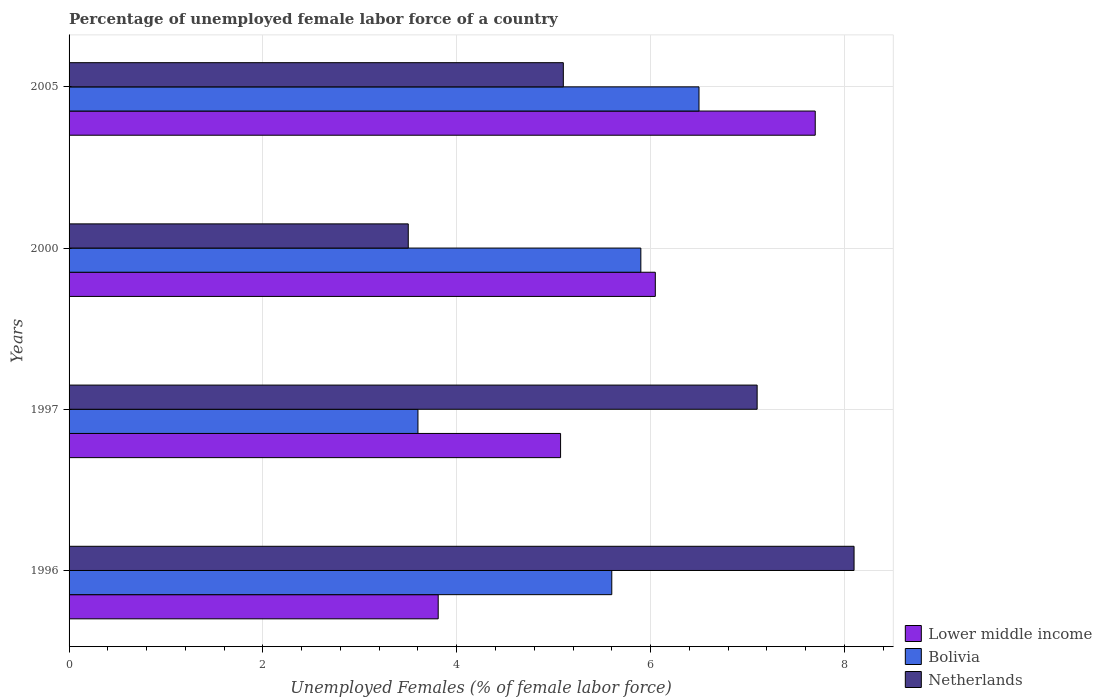How many different coloured bars are there?
Make the answer very short. 3. How many bars are there on the 4th tick from the top?
Your answer should be compact. 3. How many bars are there on the 4th tick from the bottom?
Make the answer very short. 3. What is the label of the 2nd group of bars from the top?
Keep it short and to the point. 2000. In how many cases, is the number of bars for a given year not equal to the number of legend labels?
Offer a terse response. 0. What is the percentage of unemployed female labor force in Lower middle income in 2005?
Your response must be concise. 7.7. Across all years, what is the maximum percentage of unemployed female labor force in Netherlands?
Provide a short and direct response. 8.1. Across all years, what is the minimum percentage of unemployed female labor force in Lower middle income?
Your answer should be very brief. 3.81. In which year was the percentage of unemployed female labor force in Lower middle income maximum?
Your answer should be compact. 2005. What is the total percentage of unemployed female labor force in Lower middle income in the graph?
Provide a short and direct response. 22.63. What is the difference between the percentage of unemployed female labor force in Bolivia in 1997 and that in 2005?
Offer a very short reply. -2.9. What is the difference between the percentage of unemployed female labor force in Bolivia in 2005 and the percentage of unemployed female labor force in Netherlands in 1997?
Keep it short and to the point. -0.6. What is the average percentage of unemployed female labor force in Lower middle income per year?
Ensure brevity in your answer.  5.66. In the year 1997, what is the difference between the percentage of unemployed female labor force in Netherlands and percentage of unemployed female labor force in Bolivia?
Your answer should be very brief. 3.5. What is the ratio of the percentage of unemployed female labor force in Bolivia in 1996 to that in 2000?
Provide a short and direct response. 0.95. Is the percentage of unemployed female labor force in Bolivia in 2000 less than that in 2005?
Provide a short and direct response. Yes. Is the difference between the percentage of unemployed female labor force in Netherlands in 2000 and 2005 greater than the difference between the percentage of unemployed female labor force in Bolivia in 2000 and 2005?
Your answer should be very brief. No. What is the difference between the highest and the second highest percentage of unemployed female labor force in Bolivia?
Ensure brevity in your answer.  0.6. What is the difference between the highest and the lowest percentage of unemployed female labor force in Netherlands?
Provide a succinct answer. 4.6. Is the sum of the percentage of unemployed female labor force in Netherlands in 1996 and 1997 greater than the maximum percentage of unemployed female labor force in Bolivia across all years?
Ensure brevity in your answer.  Yes. What does the 1st bar from the bottom in 1996 represents?
Make the answer very short. Lower middle income. Are all the bars in the graph horizontal?
Your answer should be very brief. Yes. How many years are there in the graph?
Provide a short and direct response. 4. What is the difference between two consecutive major ticks on the X-axis?
Ensure brevity in your answer.  2. Are the values on the major ticks of X-axis written in scientific E-notation?
Offer a very short reply. No. Where does the legend appear in the graph?
Offer a terse response. Bottom right. How many legend labels are there?
Make the answer very short. 3. How are the legend labels stacked?
Provide a succinct answer. Vertical. What is the title of the graph?
Your answer should be very brief. Percentage of unemployed female labor force of a country. Does "United Arab Emirates" appear as one of the legend labels in the graph?
Provide a short and direct response. No. What is the label or title of the X-axis?
Your answer should be compact. Unemployed Females (% of female labor force). What is the Unemployed Females (% of female labor force) in Lower middle income in 1996?
Your answer should be compact. 3.81. What is the Unemployed Females (% of female labor force) of Bolivia in 1996?
Your response must be concise. 5.6. What is the Unemployed Females (% of female labor force) of Netherlands in 1996?
Ensure brevity in your answer.  8.1. What is the Unemployed Females (% of female labor force) of Lower middle income in 1997?
Ensure brevity in your answer.  5.07. What is the Unemployed Females (% of female labor force) in Bolivia in 1997?
Keep it short and to the point. 3.6. What is the Unemployed Females (% of female labor force) of Netherlands in 1997?
Keep it short and to the point. 7.1. What is the Unemployed Females (% of female labor force) of Lower middle income in 2000?
Provide a short and direct response. 6.05. What is the Unemployed Females (% of female labor force) of Bolivia in 2000?
Provide a succinct answer. 5.9. What is the Unemployed Females (% of female labor force) of Lower middle income in 2005?
Keep it short and to the point. 7.7. What is the Unemployed Females (% of female labor force) in Bolivia in 2005?
Ensure brevity in your answer.  6.5. What is the Unemployed Females (% of female labor force) of Netherlands in 2005?
Provide a short and direct response. 5.1. Across all years, what is the maximum Unemployed Females (% of female labor force) in Lower middle income?
Offer a terse response. 7.7. Across all years, what is the maximum Unemployed Females (% of female labor force) of Netherlands?
Your response must be concise. 8.1. Across all years, what is the minimum Unemployed Females (% of female labor force) in Lower middle income?
Make the answer very short. 3.81. Across all years, what is the minimum Unemployed Females (% of female labor force) in Bolivia?
Your answer should be compact. 3.6. What is the total Unemployed Females (% of female labor force) in Lower middle income in the graph?
Your answer should be compact. 22.63. What is the total Unemployed Females (% of female labor force) of Bolivia in the graph?
Keep it short and to the point. 21.6. What is the total Unemployed Females (% of female labor force) of Netherlands in the graph?
Provide a short and direct response. 23.8. What is the difference between the Unemployed Females (% of female labor force) in Lower middle income in 1996 and that in 1997?
Ensure brevity in your answer.  -1.26. What is the difference between the Unemployed Females (% of female labor force) in Bolivia in 1996 and that in 1997?
Keep it short and to the point. 2. What is the difference between the Unemployed Females (% of female labor force) in Lower middle income in 1996 and that in 2000?
Offer a very short reply. -2.24. What is the difference between the Unemployed Females (% of female labor force) in Bolivia in 1996 and that in 2000?
Your answer should be very brief. -0.3. What is the difference between the Unemployed Females (% of female labor force) in Netherlands in 1996 and that in 2000?
Provide a short and direct response. 4.6. What is the difference between the Unemployed Females (% of female labor force) of Lower middle income in 1996 and that in 2005?
Offer a very short reply. -3.89. What is the difference between the Unemployed Females (% of female labor force) in Bolivia in 1996 and that in 2005?
Your answer should be very brief. -0.9. What is the difference between the Unemployed Females (% of female labor force) in Netherlands in 1996 and that in 2005?
Keep it short and to the point. 3. What is the difference between the Unemployed Females (% of female labor force) in Lower middle income in 1997 and that in 2000?
Provide a succinct answer. -0.98. What is the difference between the Unemployed Females (% of female labor force) of Bolivia in 1997 and that in 2000?
Give a very brief answer. -2.3. What is the difference between the Unemployed Females (% of female labor force) of Netherlands in 1997 and that in 2000?
Keep it short and to the point. 3.6. What is the difference between the Unemployed Females (% of female labor force) of Lower middle income in 1997 and that in 2005?
Your answer should be very brief. -2.63. What is the difference between the Unemployed Females (% of female labor force) of Bolivia in 1997 and that in 2005?
Provide a short and direct response. -2.9. What is the difference between the Unemployed Females (% of female labor force) in Lower middle income in 2000 and that in 2005?
Offer a terse response. -1.65. What is the difference between the Unemployed Females (% of female labor force) of Lower middle income in 1996 and the Unemployed Females (% of female labor force) of Bolivia in 1997?
Your answer should be very brief. 0.21. What is the difference between the Unemployed Females (% of female labor force) of Lower middle income in 1996 and the Unemployed Females (% of female labor force) of Netherlands in 1997?
Give a very brief answer. -3.29. What is the difference between the Unemployed Females (% of female labor force) of Bolivia in 1996 and the Unemployed Females (% of female labor force) of Netherlands in 1997?
Ensure brevity in your answer.  -1.5. What is the difference between the Unemployed Females (% of female labor force) of Lower middle income in 1996 and the Unemployed Females (% of female labor force) of Bolivia in 2000?
Your answer should be compact. -2.09. What is the difference between the Unemployed Females (% of female labor force) in Lower middle income in 1996 and the Unemployed Females (% of female labor force) in Netherlands in 2000?
Your response must be concise. 0.31. What is the difference between the Unemployed Females (% of female labor force) of Bolivia in 1996 and the Unemployed Females (% of female labor force) of Netherlands in 2000?
Give a very brief answer. 2.1. What is the difference between the Unemployed Females (% of female labor force) of Lower middle income in 1996 and the Unemployed Females (% of female labor force) of Bolivia in 2005?
Provide a succinct answer. -2.69. What is the difference between the Unemployed Females (% of female labor force) in Lower middle income in 1996 and the Unemployed Females (% of female labor force) in Netherlands in 2005?
Provide a succinct answer. -1.29. What is the difference between the Unemployed Females (% of female labor force) of Bolivia in 1996 and the Unemployed Females (% of female labor force) of Netherlands in 2005?
Provide a succinct answer. 0.5. What is the difference between the Unemployed Females (% of female labor force) of Lower middle income in 1997 and the Unemployed Females (% of female labor force) of Bolivia in 2000?
Your answer should be very brief. -0.83. What is the difference between the Unemployed Females (% of female labor force) in Lower middle income in 1997 and the Unemployed Females (% of female labor force) in Netherlands in 2000?
Offer a terse response. 1.57. What is the difference between the Unemployed Females (% of female labor force) of Lower middle income in 1997 and the Unemployed Females (% of female labor force) of Bolivia in 2005?
Ensure brevity in your answer.  -1.43. What is the difference between the Unemployed Females (% of female labor force) of Lower middle income in 1997 and the Unemployed Females (% of female labor force) of Netherlands in 2005?
Provide a short and direct response. -0.03. What is the difference between the Unemployed Females (% of female labor force) of Bolivia in 1997 and the Unemployed Females (% of female labor force) of Netherlands in 2005?
Keep it short and to the point. -1.5. What is the difference between the Unemployed Females (% of female labor force) of Lower middle income in 2000 and the Unemployed Females (% of female labor force) of Bolivia in 2005?
Offer a terse response. -0.45. What is the difference between the Unemployed Females (% of female labor force) in Lower middle income in 2000 and the Unemployed Females (% of female labor force) in Netherlands in 2005?
Offer a terse response. 0.95. What is the difference between the Unemployed Females (% of female labor force) of Bolivia in 2000 and the Unemployed Females (% of female labor force) of Netherlands in 2005?
Provide a succinct answer. 0.8. What is the average Unemployed Females (% of female labor force) in Lower middle income per year?
Provide a succinct answer. 5.66. What is the average Unemployed Females (% of female labor force) in Netherlands per year?
Make the answer very short. 5.95. In the year 1996, what is the difference between the Unemployed Females (% of female labor force) in Lower middle income and Unemployed Females (% of female labor force) in Bolivia?
Give a very brief answer. -1.79. In the year 1996, what is the difference between the Unemployed Females (% of female labor force) of Lower middle income and Unemployed Females (% of female labor force) of Netherlands?
Provide a short and direct response. -4.29. In the year 1996, what is the difference between the Unemployed Females (% of female labor force) in Bolivia and Unemployed Females (% of female labor force) in Netherlands?
Keep it short and to the point. -2.5. In the year 1997, what is the difference between the Unemployed Females (% of female labor force) of Lower middle income and Unemployed Females (% of female labor force) of Bolivia?
Make the answer very short. 1.47. In the year 1997, what is the difference between the Unemployed Females (% of female labor force) of Lower middle income and Unemployed Females (% of female labor force) of Netherlands?
Provide a short and direct response. -2.03. In the year 1997, what is the difference between the Unemployed Females (% of female labor force) of Bolivia and Unemployed Females (% of female labor force) of Netherlands?
Offer a very short reply. -3.5. In the year 2000, what is the difference between the Unemployed Females (% of female labor force) in Lower middle income and Unemployed Females (% of female labor force) in Bolivia?
Provide a short and direct response. 0.15. In the year 2000, what is the difference between the Unemployed Females (% of female labor force) in Lower middle income and Unemployed Females (% of female labor force) in Netherlands?
Offer a very short reply. 2.55. In the year 2000, what is the difference between the Unemployed Females (% of female labor force) in Bolivia and Unemployed Females (% of female labor force) in Netherlands?
Make the answer very short. 2.4. In the year 2005, what is the difference between the Unemployed Females (% of female labor force) in Lower middle income and Unemployed Females (% of female labor force) in Bolivia?
Offer a terse response. 1.2. In the year 2005, what is the difference between the Unemployed Females (% of female labor force) of Lower middle income and Unemployed Females (% of female labor force) of Netherlands?
Offer a terse response. 2.6. In the year 2005, what is the difference between the Unemployed Females (% of female labor force) in Bolivia and Unemployed Females (% of female labor force) in Netherlands?
Your response must be concise. 1.4. What is the ratio of the Unemployed Females (% of female labor force) in Lower middle income in 1996 to that in 1997?
Give a very brief answer. 0.75. What is the ratio of the Unemployed Females (% of female labor force) of Bolivia in 1996 to that in 1997?
Your response must be concise. 1.56. What is the ratio of the Unemployed Females (% of female labor force) of Netherlands in 1996 to that in 1997?
Your answer should be very brief. 1.14. What is the ratio of the Unemployed Females (% of female labor force) of Lower middle income in 1996 to that in 2000?
Provide a short and direct response. 0.63. What is the ratio of the Unemployed Females (% of female labor force) of Bolivia in 1996 to that in 2000?
Offer a very short reply. 0.95. What is the ratio of the Unemployed Females (% of female labor force) in Netherlands in 1996 to that in 2000?
Your answer should be very brief. 2.31. What is the ratio of the Unemployed Females (% of female labor force) in Lower middle income in 1996 to that in 2005?
Provide a succinct answer. 0.49. What is the ratio of the Unemployed Females (% of female labor force) of Bolivia in 1996 to that in 2005?
Your answer should be compact. 0.86. What is the ratio of the Unemployed Females (% of female labor force) of Netherlands in 1996 to that in 2005?
Offer a terse response. 1.59. What is the ratio of the Unemployed Females (% of female labor force) in Lower middle income in 1997 to that in 2000?
Offer a very short reply. 0.84. What is the ratio of the Unemployed Females (% of female labor force) of Bolivia in 1997 to that in 2000?
Offer a very short reply. 0.61. What is the ratio of the Unemployed Females (% of female labor force) in Netherlands in 1997 to that in 2000?
Your answer should be very brief. 2.03. What is the ratio of the Unemployed Females (% of female labor force) of Lower middle income in 1997 to that in 2005?
Make the answer very short. 0.66. What is the ratio of the Unemployed Females (% of female labor force) in Bolivia in 1997 to that in 2005?
Ensure brevity in your answer.  0.55. What is the ratio of the Unemployed Females (% of female labor force) in Netherlands in 1997 to that in 2005?
Offer a terse response. 1.39. What is the ratio of the Unemployed Females (% of female labor force) of Lower middle income in 2000 to that in 2005?
Your answer should be very brief. 0.79. What is the ratio of the Unemployed Females (% of female labor force) of Bolivia in 2000 to that in 2005?
Provide a short and direct response. 0.91. What is the ratio of the Unemployed Females (% of female labor force) in Netherlands in 2000 to that in 2005?
Your answer should be very brief. 0.69. What is the difference between the highest and the second highest Unemployed Females (% of female labor force) of Lower middle income?
Provide a short and direct response. 1.65. What is the difference between the highest and the lowest Unemployed Females (% of female labor force) of Lower middle income?
Make the answer very short. 3.89. 